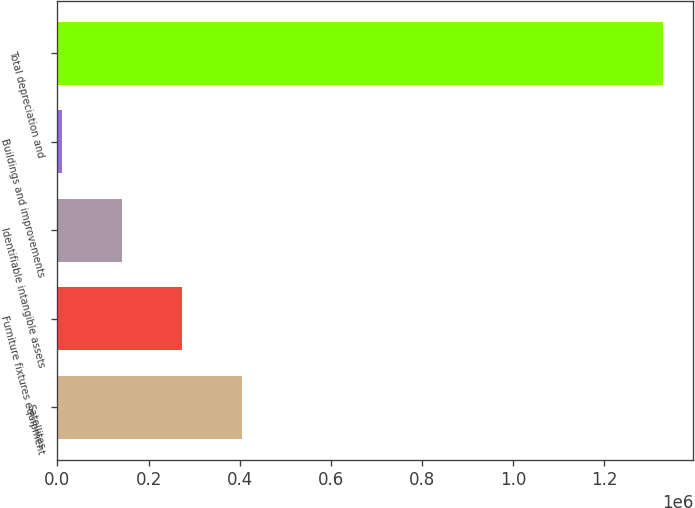Convert chart to OTSL. <chart><loc_0><loc_0><loc_500><loc_500><bar_chart><fcel>Satellites<fcel>Furniture fixtures equipment<fcel>Identifiable intangible assets<fcel>Buildings and improvements<fcel>Total depreciation and<nl><fcel>405670<fcel>273707<fcel>141744<fcel>9781<fcel>1.32941e+06<nl></chart> 